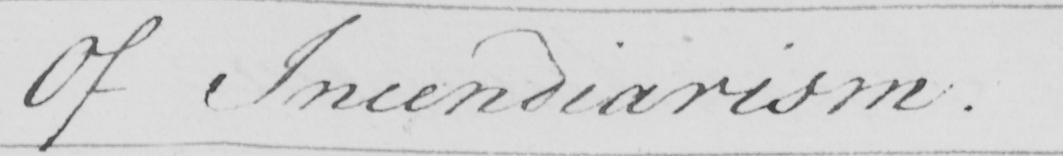What is written in this line of handwriting? Of Incendiarism . 